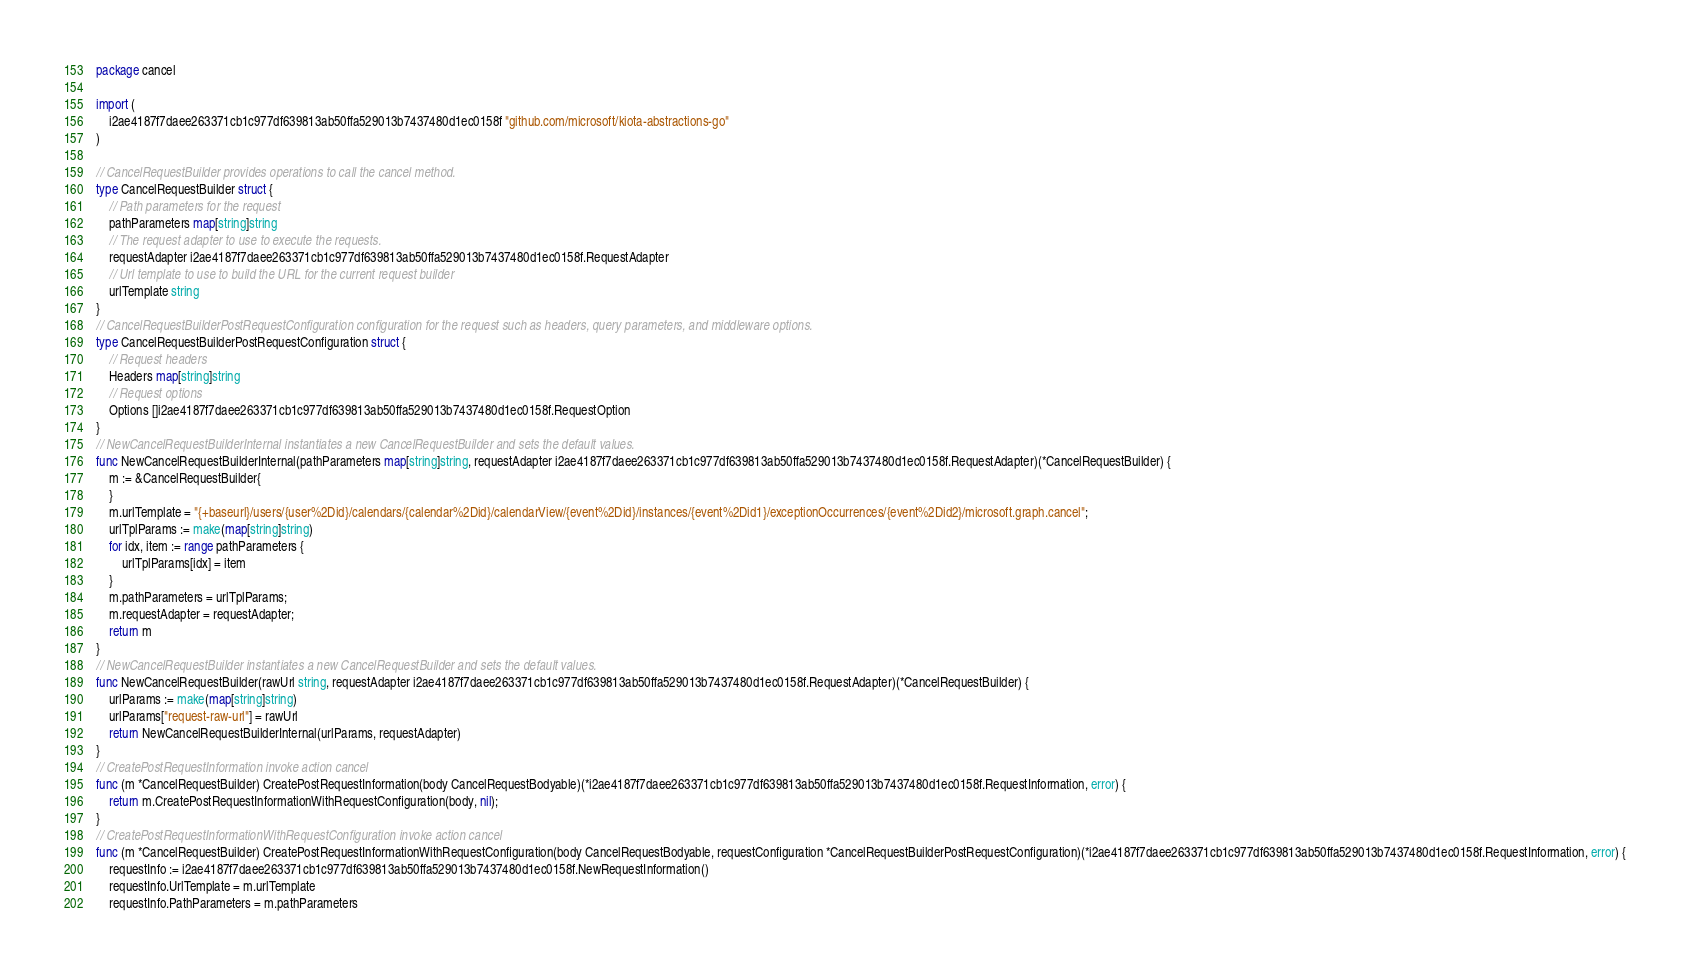Convert code to text. <code><loc_0><loc_0><loc_500><loc_500><_Go_>package cancel

import (
    i2ae4187f7daee263371cb1c977df639813ab50ffa529013b7437480d1ec0158f "github.com/microsoft/kiota-abstractions-go"
)

// CancelRequestBuilder provides operations to call the cancel method.
type CancelRequestBuilder struct {
    // Path parameters for the request
    pathParameters map[string]string
    // The request adapter to use to execute the requests.
    requestAdapter i2ae4187f7daee263371cb1c977df639813ab50ffa529013b7437480d1ec0158f.RequestAdapter
    // Url template to use to build the URL for the current request builder
    urlTemplate string
}
// CancelRequestBuilderPostRequestConfiguration configuration for the request such as headers, query parameters, and middleware options.
type CancelRequestBuilderPostRequestConfiguration struct {
    // Request headers
    Headers map[string]string
    // Request options
    Options []i2ae4187f7daee263371cb1c977df639813ab50ffa529013b7437480d1ec0158f.RequestOption
}
// NewCancelRequestBuilderInternal instantiates a new CancelRequestBuilder and sets the default values.
func NewCancelRequestBuilderInternal(pathParameters map[string]string, requestAdapter i2ae4187f7daee263371cb1c977df639813ab50ffa529013b7437480d1ec0158f.RequestAdapter)(*CancelRequestBuilder) {
    m := &CancelRequestBuilder{
    }
    m.urlTemplate = "{+baseurl}/users/{user%2Did}/calendars/{calendar%2Did}/calendarView/{event%2Did}/instances/{event%2Did1}/exceptionOccurrences/{event%2Did2}/microsoft.graph.cancel";
    urlTplParams := make(map[string]string)
    for idx, item := range pathParameters {
        urlTplParams[idx] = item
    }
    m.pathParameters = urlTplParams;
    m.requestAdapter = requestAdapter;
    return m
}
// NewCancelRequestBuilder instantiates a new CancelRequestBuilder and sets the default values.
func NewCancelRequestBuilder(rawUrl string, requestAdapter i2ae4187f7daee263371cb1c977df639813ab50ffa529013b7437480d1ec0158f.RequestAdapter)(*CancelRequestBuilder) {
    urlParams := make(map[string]string)
    urlParams["request-raw-url"] = rawUrl
    return NewCancelRequestBuilderInternal(urlParams, requestAdapter)
}
// CreatePostRequestInformation invoke action cancel
func (m *CancelRequestBuilder) CreatePostRequestInformation(body CancelRequestBodyable)(*i2ae4187f7daee263371cb1c977df639813ab50ffa529013b7437480d1ec0158f.RequestInformation, error) {
    return m.CreatePostRequestInformationWithRequestConfiguration(body, nil);
}
// CreatePostRequestInformationWithRequestConfiguration invoke action cancel
func (m *CancelRequestBuilder) CreatePostRequestInformationWithRequestConfiguration(body CancelRequestBodyable, requestConfiguration *CancelRequestBuilderPostRequestConfiguration)(*i2ae4187f7daee263371cb1c977df639813ab50ffa529013b7437480d1ec0158f.RequestInformation, error) {
    requestInfo := i2ae4187f7daee263371cb1c977df639813ab50ffa529013b7437480d1ec0158f.NewRequestInformation()
    requestInfo.UrlTemplate = m.urlTemplate
    requestInfo.PathParameters = m.pathParameters</code> 